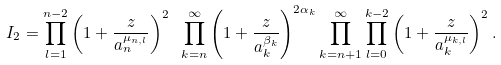<formula> <loc_0><loc_0><loc_500><loc_500>I _ { 2 } = \prod _ { l = 1 } ^ { n - 2 } \left ( 1 + \frac { z } { a _ { n } ^ { \mu _ { n , l } } } \right ) ^ { 2 } \ \prod _ { k = n } ^ { \infty } \left ( 1 + \frac { z } { a _ { k } ^ { \beta _ { k } } } \right ) ^ { 2 \alpha _ { k } } \prod _ { k = n + 1 } ^ { \infty } \prod _ { l = 0 } ^ { k - 2 } \left ( 1 + \frac { z } { a _ { k } ^ { \mu _ { k , l } } } \right ) ^ { 2 } .</formula> 